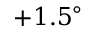Convert formula to latex. <formula><loc_0><loc_0><loc_500><loc_500>+ 1 . 5 ^ { \circ }</formula> 